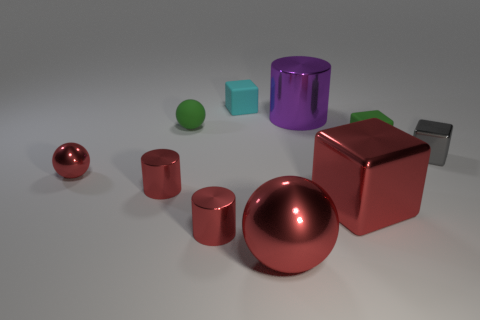Subtract all balls. How many objects are left? 7 Subtract 0 purple blocks. How many objects are left? 10 Subtract all green rubber blocks. Subtract all large yellow objects. How many objects are left? 9 Add 2 tiny shiny cylinders. How many tiny shiny cylinders are left? 4 Add 8 large purple cylinders. How many large purple cylinders exist? 9 